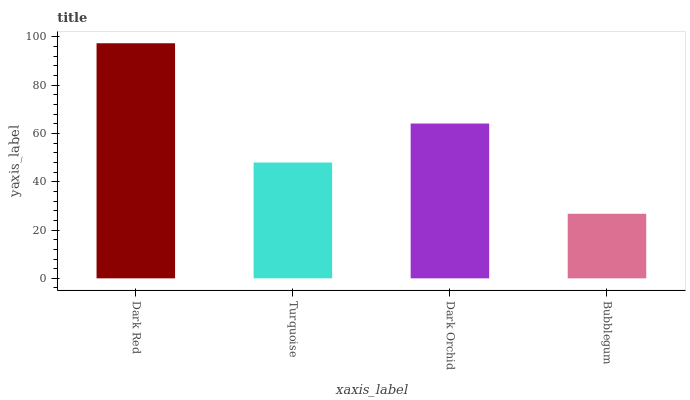Is Bubblegum the minimum?
Answer yes or no. Yes. Is Dark Red the maximum?
Answer yes or no. Yes. Is Turquoise the minimum?
Answer yes or no. No. Is Turquoise the maximum?
Answer yes or no. No. Is Dark Red greater than Turquoise?
Answer yes or no. Yes. Is Turquoise less than Dark Red?
Answer yes or no. Yes. Is Turquoise greater than Dark Red?
Answer yes or no. No. Is Dark Red less than Turquoise?
Answer yes or no. No. Is Dark Orchid the high median?
Answer yes or no. Yes. Is Turquoise the low median?
Answer yes or no. Yes. Is Dark Red the high median?
Answer yes or no. No. Is Dark Orchid the low median?
Answer yes or no. No. 